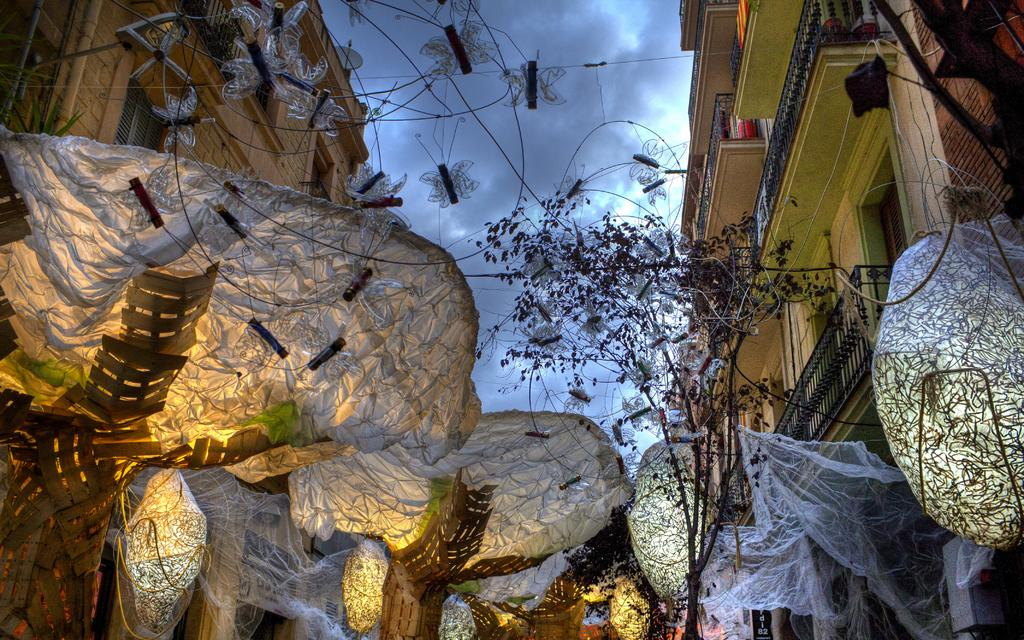What type of structures can be seen in the image? There are buildings in the image. What else is present in the image besides the buildings? There is decoration, a plant, a fence, and leaves in the image. Can you describe the plant in the image? The plant has leaves, as mentioned in the facts. What is the condition of the sky in the image? The sky is cloudy in the image. What type of brass material can be seen on the back of the plant in the image? There is no brass material present in the image, and the plant does not have a back. 